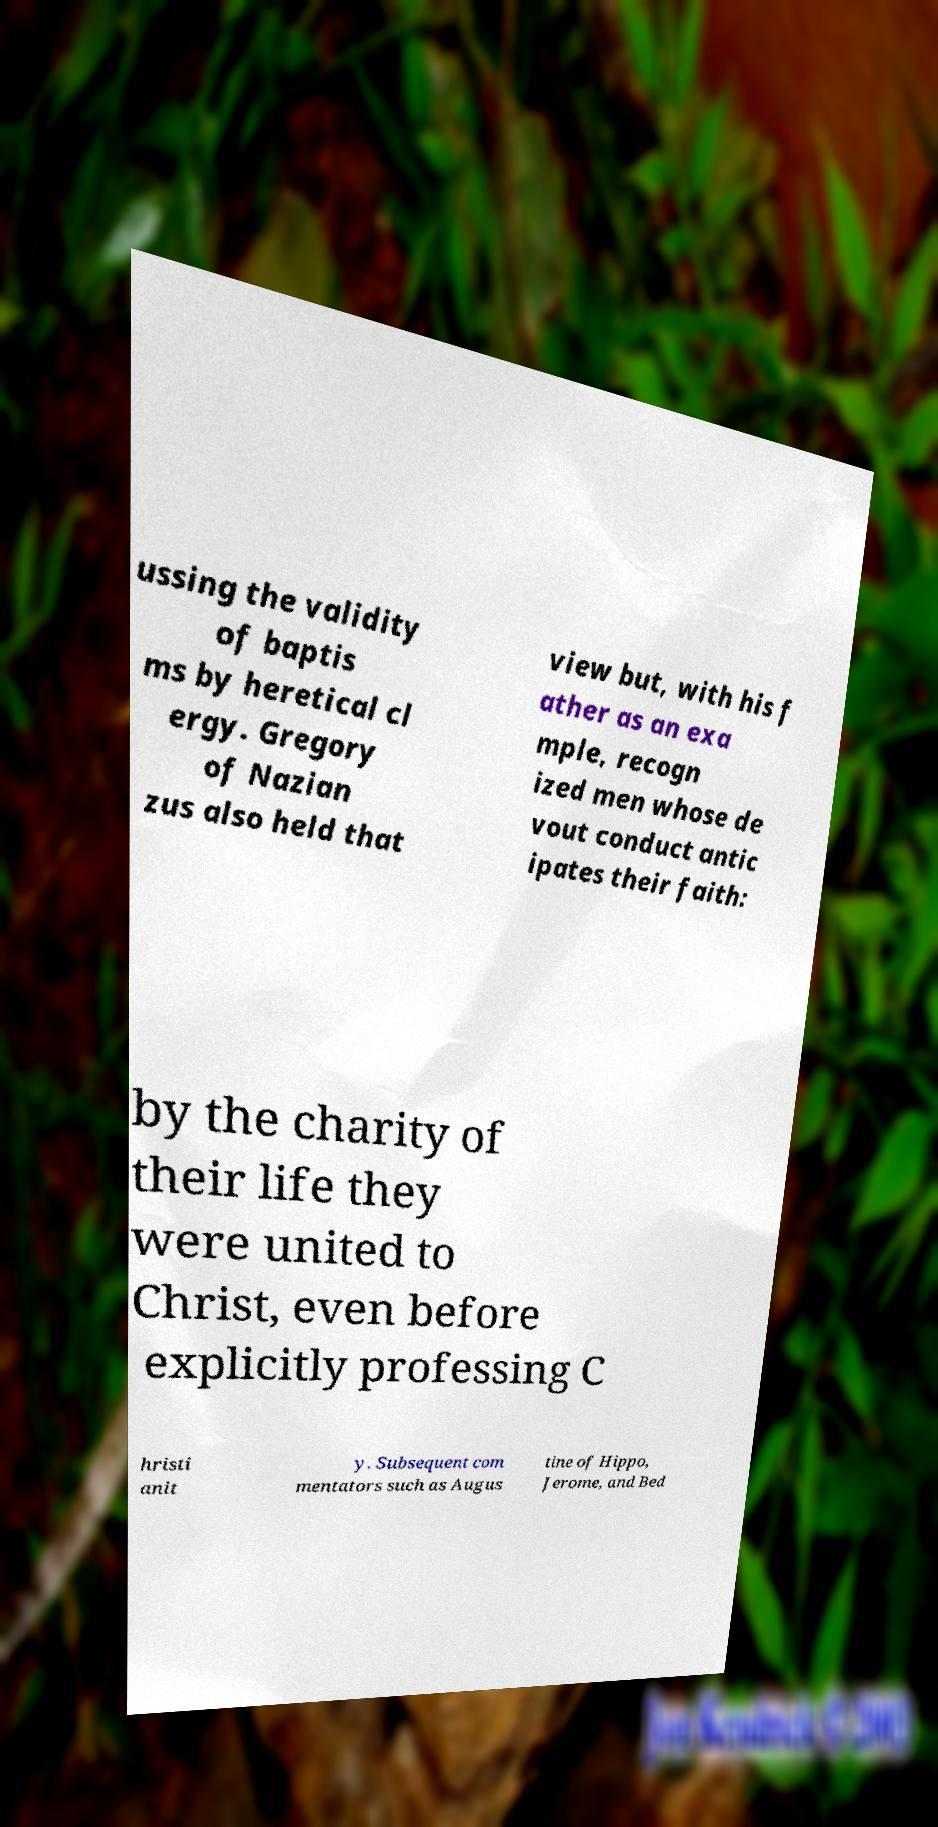For documentation purposes, I need the text within this image transcribed. Could you provide that? ussing the validity of baptis ms by heretical cl ergy. Gregory of Nazian zus also held that view but, with his f ather as an exa mple, recogn ized men whose de vout conduct antic ipates their faith: by the charity of their life they were united to Christ, even before explicitly professing C hristi anit y. Subsequent com mentators such as Augus tine of Hippo, Jerome, and Bed 